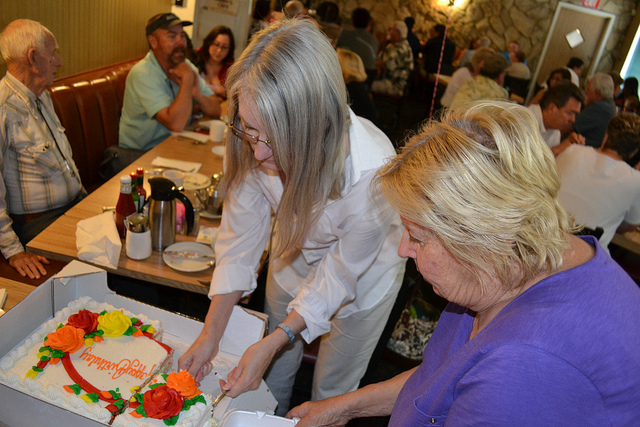Read all the text in this image. Happy Birthday 